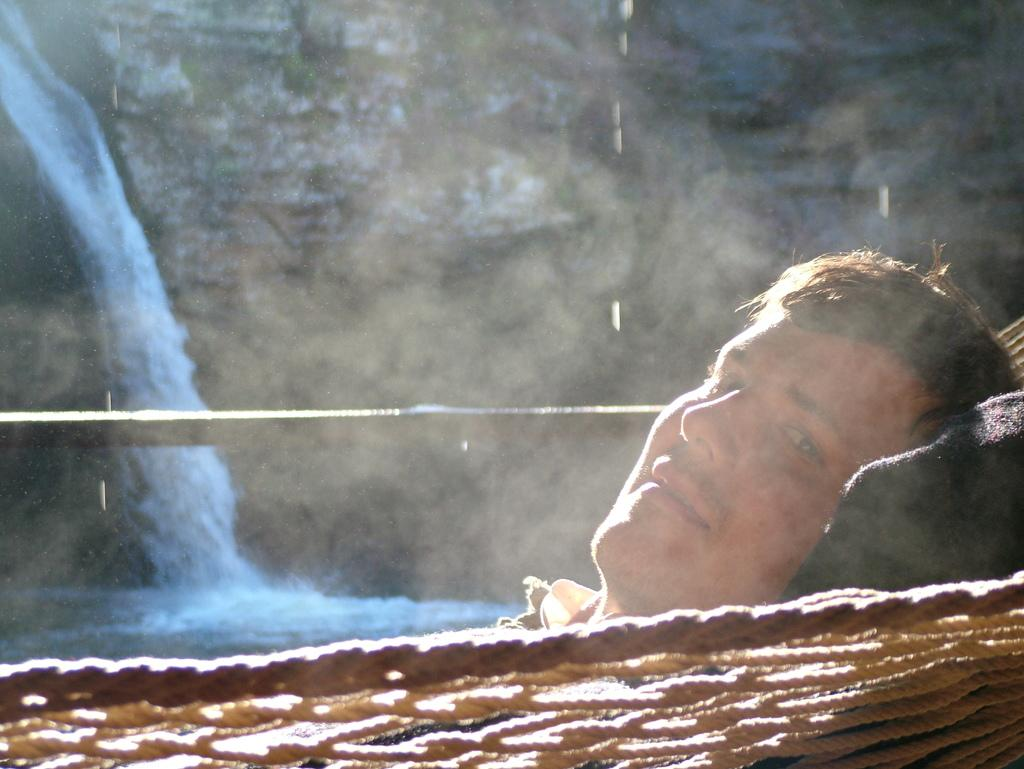What is the main subject of the image? There is a person's face in the image. What can be seen in the background of the image? There is a waterfall and a mountain in the background of the image. What color are the waterfall and mountain in the image? The waterfall and mountain are in blue. What is the person's interest in the image? The image does not provide information about the person's interests. How is the waterfall being used in the image? The image does not show the waterfall being used for any specific purpose. 